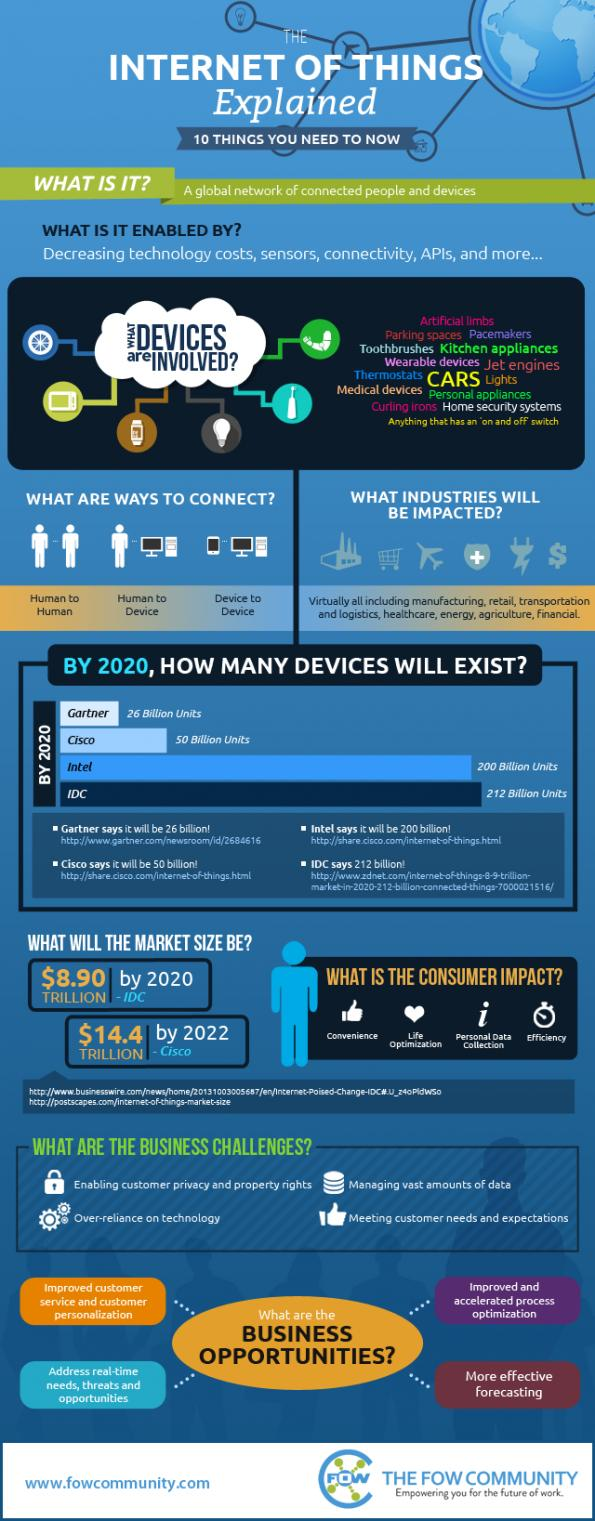Identify some key points in this picture. By 2020, it is projected that a certain company will have more devices than IDC. Cisco is expected to have more devices by 2020 than Gartner, according to a prediction. The Internet of Things technology enables various types of connections between humans, devices, and other devices, including human-to-human connections, device-to-human connections, and device-to-device connections. Over-reliance on technology is the third challenge in the list of business challenges. By 2020, it is projected that a specific company will have sold more devices than any other company in the industry, according to a report by Gartner. 